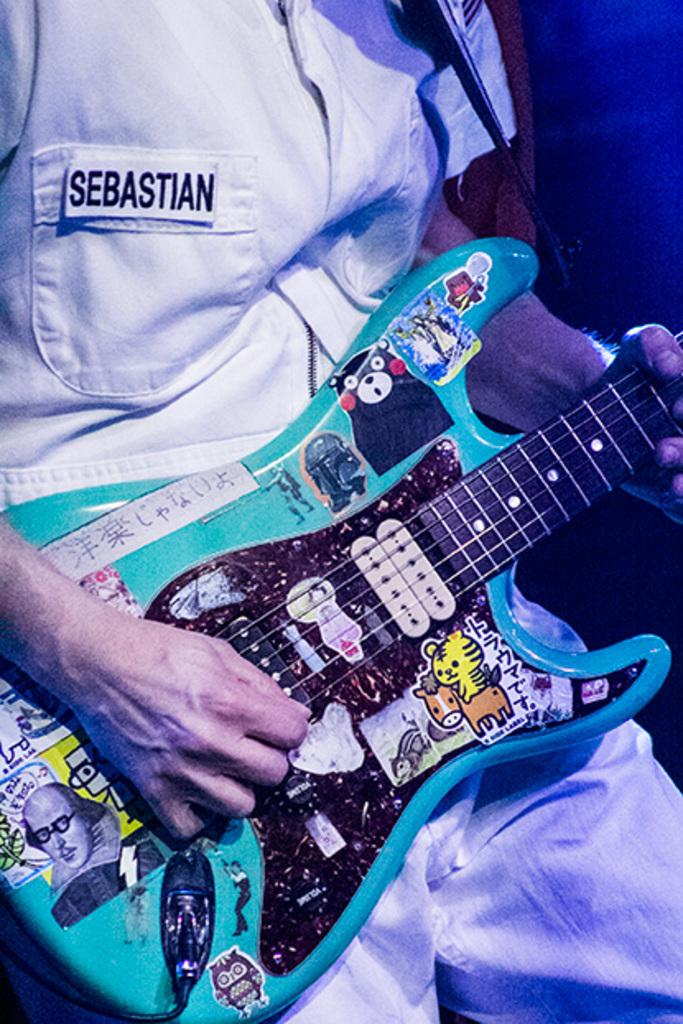What is the main subject of the image? There is a person in the image. What is the person doing in the image? The person is holding a musical instrument. Can you describe the person's clothing in the image? There is text written on the person's shirt. How many basketballs can be seen in the image? There are no basketballs present in the image. What type of camera is the person using to take a picture in the image? There is no camera visible in the image, and the person is not taking a picture. 